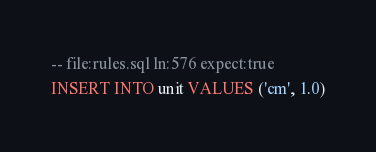<code> <loc_0><loc_0><loc_500><loc_500><_SQL_>-- file:rules.sql ln:576 expect:true
INSERT INTO unit VALUES ('cm', 1.0)
</code> 